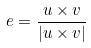<formula> <loc_0><loc_0><loc_500><loc_500>e = \frac { u \times v } { | u \times v | }</formula> 